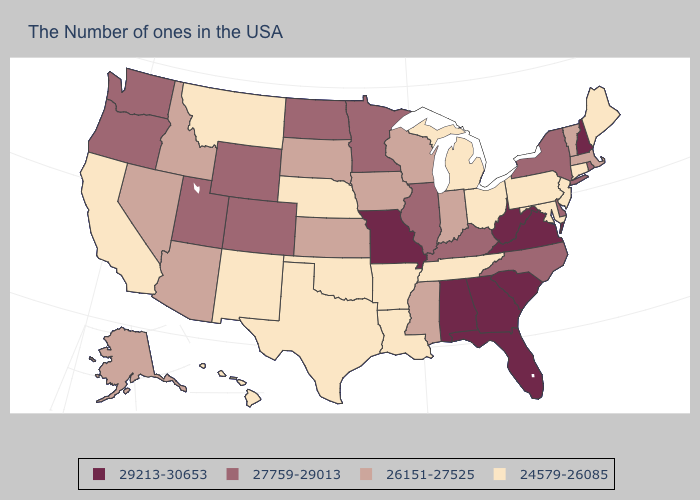What is the value of Kansas?
Concise answer only. 26151-27525. Does the map have missing data?
Concise answer only. No. How many symbols are there in the legend?
Give a very brief answer. 4. Name the states that have a value in the range 26151-27525?
Concise answer only. Massachusetts, Vermont, Indiana, Wisconsin, Mississippi, Iowa, Kansas, South Dakota, Arizona, Idaho, Nevada, Alaska. Does Indiana have the same value as Hawaii?
Write a very short answer. No. What is the highest value in the USA?
Concise answer only. 29213-30653. What is the value of Arizona?
Answer briefly. 26151-27525. What is the value of North Carolina?
Write a very short answer. 27759-29013. What is the value of Georgia?
Concise answer only. 29213-30653. Is the legend a continuous bar?
Give a very brief answer. No. Does Missouri have a higher value than South Carolina?
Concise answer only. No. Which states have the lowest value in the West?
Concise answer only. New Mexico, Montana, California, Hawaii. What is the value of New York?
Be succinct. 27759-29013. Name the states that have a value in the range 26151-27525?
Keep it brief. Massachusetts, Vermont, Indiana, Wisconsin, Mississippi, Iowa, Kansas, South Dakota, Arizona, Idaho, Nevada, Alaska. What is the highest value in the USA?
Answer briefly. 29213-30653. 